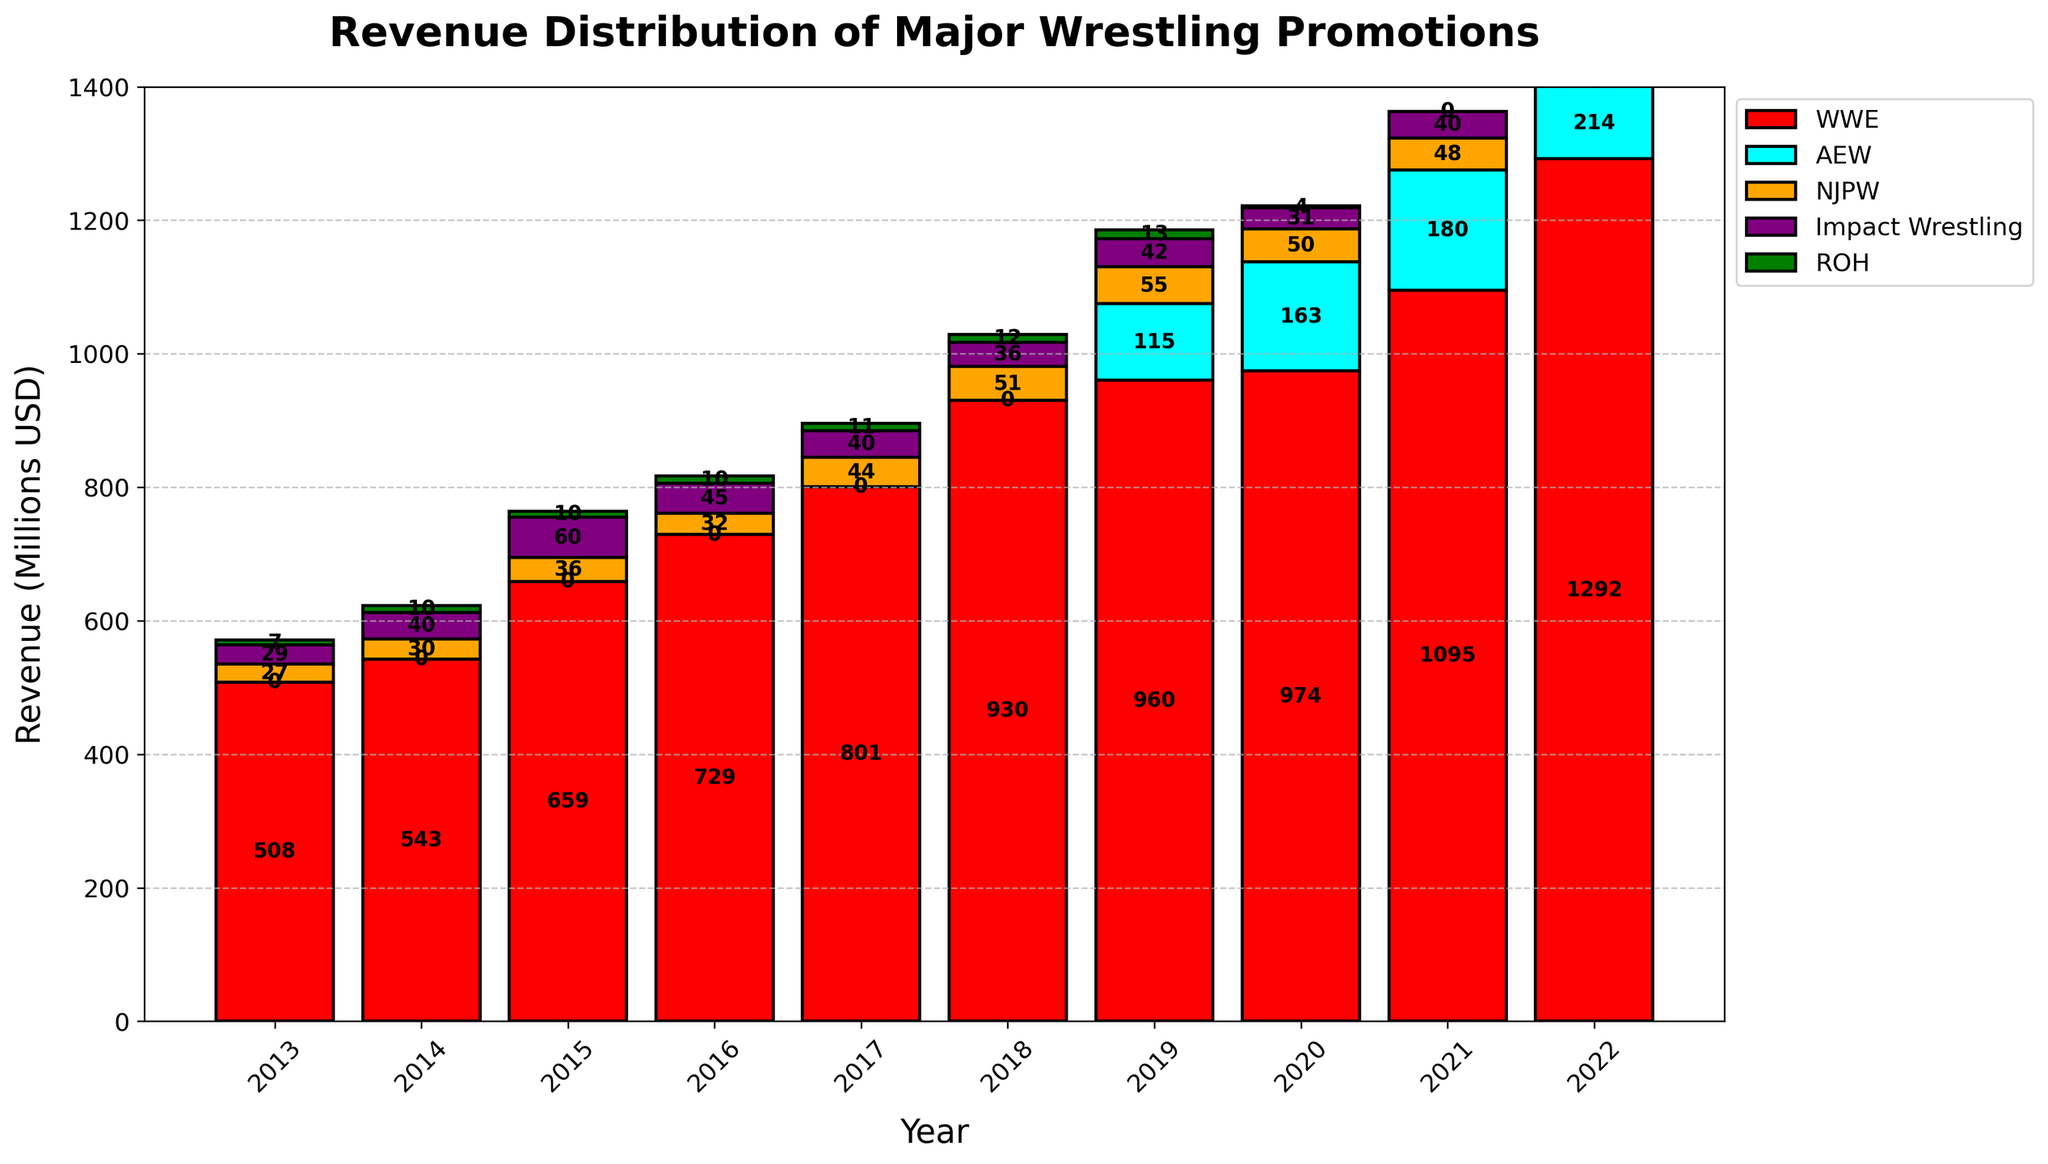Which promotion had the highest revenue in 2022? Look at the bar heights for each promotion in 2022. The highest bar corresponds to WWE.
Answer: WWE How did AEW's revenue change from 2019 to 2021? Find the height of AEW's bar in 2019 and 2021. Calculate the difference between these two revenues: (180 million - 115 million).
Answer: Increased by 65 million What was the combined revenue of NJPW and Impact Wrestling in 2022? Identify the bar heights for NJPW and Impact Wrestling in 2022. Add them together: (52 million + 45 million).
Answer: 97 million Which promotion saw a revenue decline in 2020 compared to 2019? Compare the bar heights for each promotion between 2019 and 2020. Observe that NJPW's bar is shorter in 2020 compared to 2019.
Answer: NJPW How did WWE's revenue in 2016 compare to its revenue in 2013? Look at WWE's bar heights in 2016 and 2013. Calculate the difference: (729.2 million - 508 million).
Answer: Increased by 221.2 million What was the total revenue of all promotions combined in 2020? Sum the bar heights for all promotions in 2020: (974.2 million + 163.2 million + 50 million + 31 million + 3.5 million).
Answer: 1,221.9 million Which year did AEW first appear in the revenue chart? Look at the bars for AEW, identify the first year with a bar representing AEW's revenue.
Answer: 2019 Comparing ROH’s revenue in 2014 and 2022, what is the change? Identify ROH's bar heights in 2014 and 2022. Calculate the difference: (5 million - 10 million).
Answer: Decreased by 5 million Which promotion had the smallest revenue in 2021? Compare the bar heights for each promotion in 2021. The smallest bar corresponds to NJPW.
Answer: NJPW What is the average annual revenue of Impact Wrestling from 2013 to 2022? Sum the revenues of Impact Wrestling from 2013 to 2022 and divide by 10: ((29+40+60+45+40+36+42+31+40+45) million / 10).
Answer: 40.8 million 